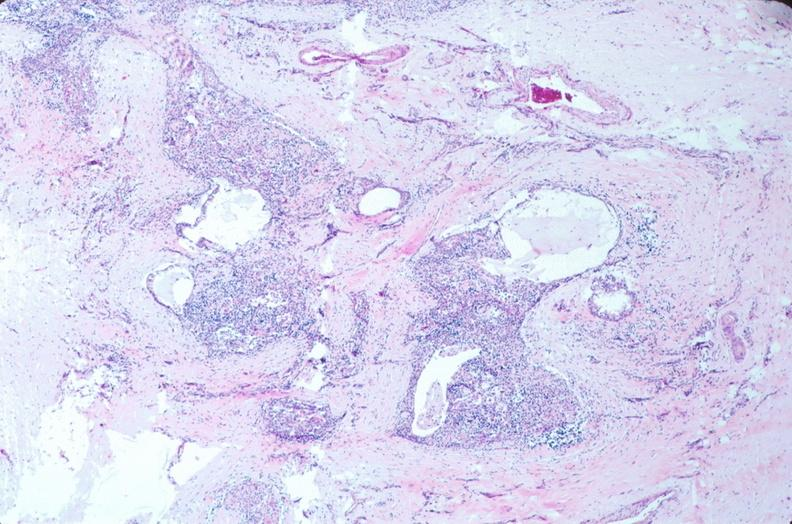what is embryo-fetus?
Answer the question using a single word or phrase. Fetus present 